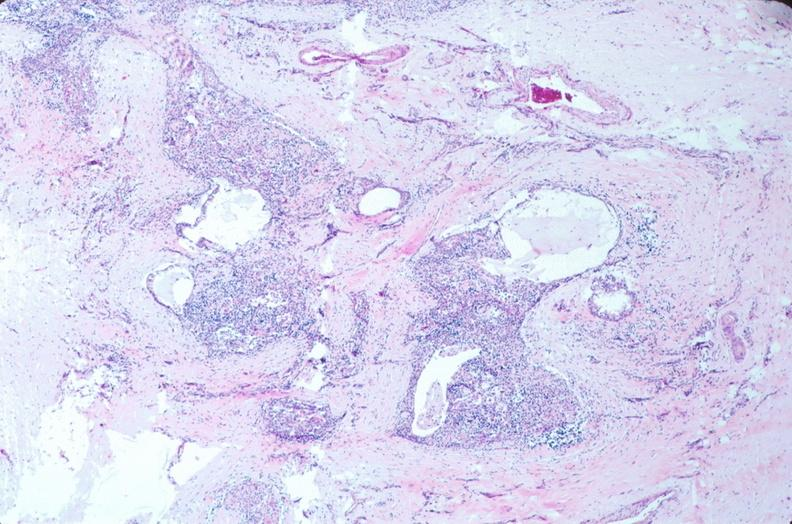what is embryo-fetus?
Answer the question using a single word or phrase. Fetus present 